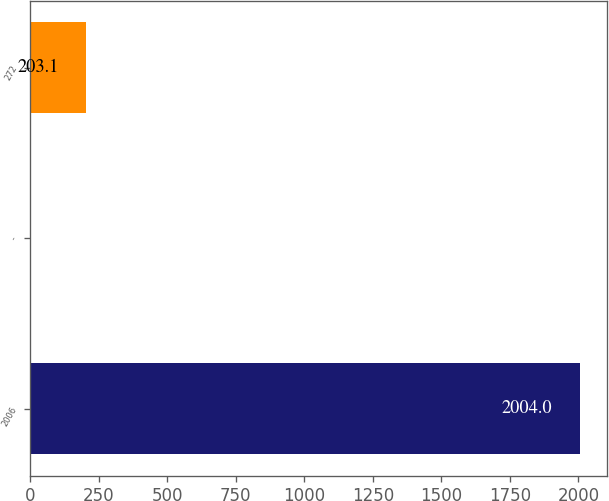Convert chart. <chart><loc_0><loc_0><loc_500><loc_500><bar_chart><fcel>2006<fcel>-<fcel>272<nl><fcel>2004<fcel>3<fcel>203.1<nl></chart> 